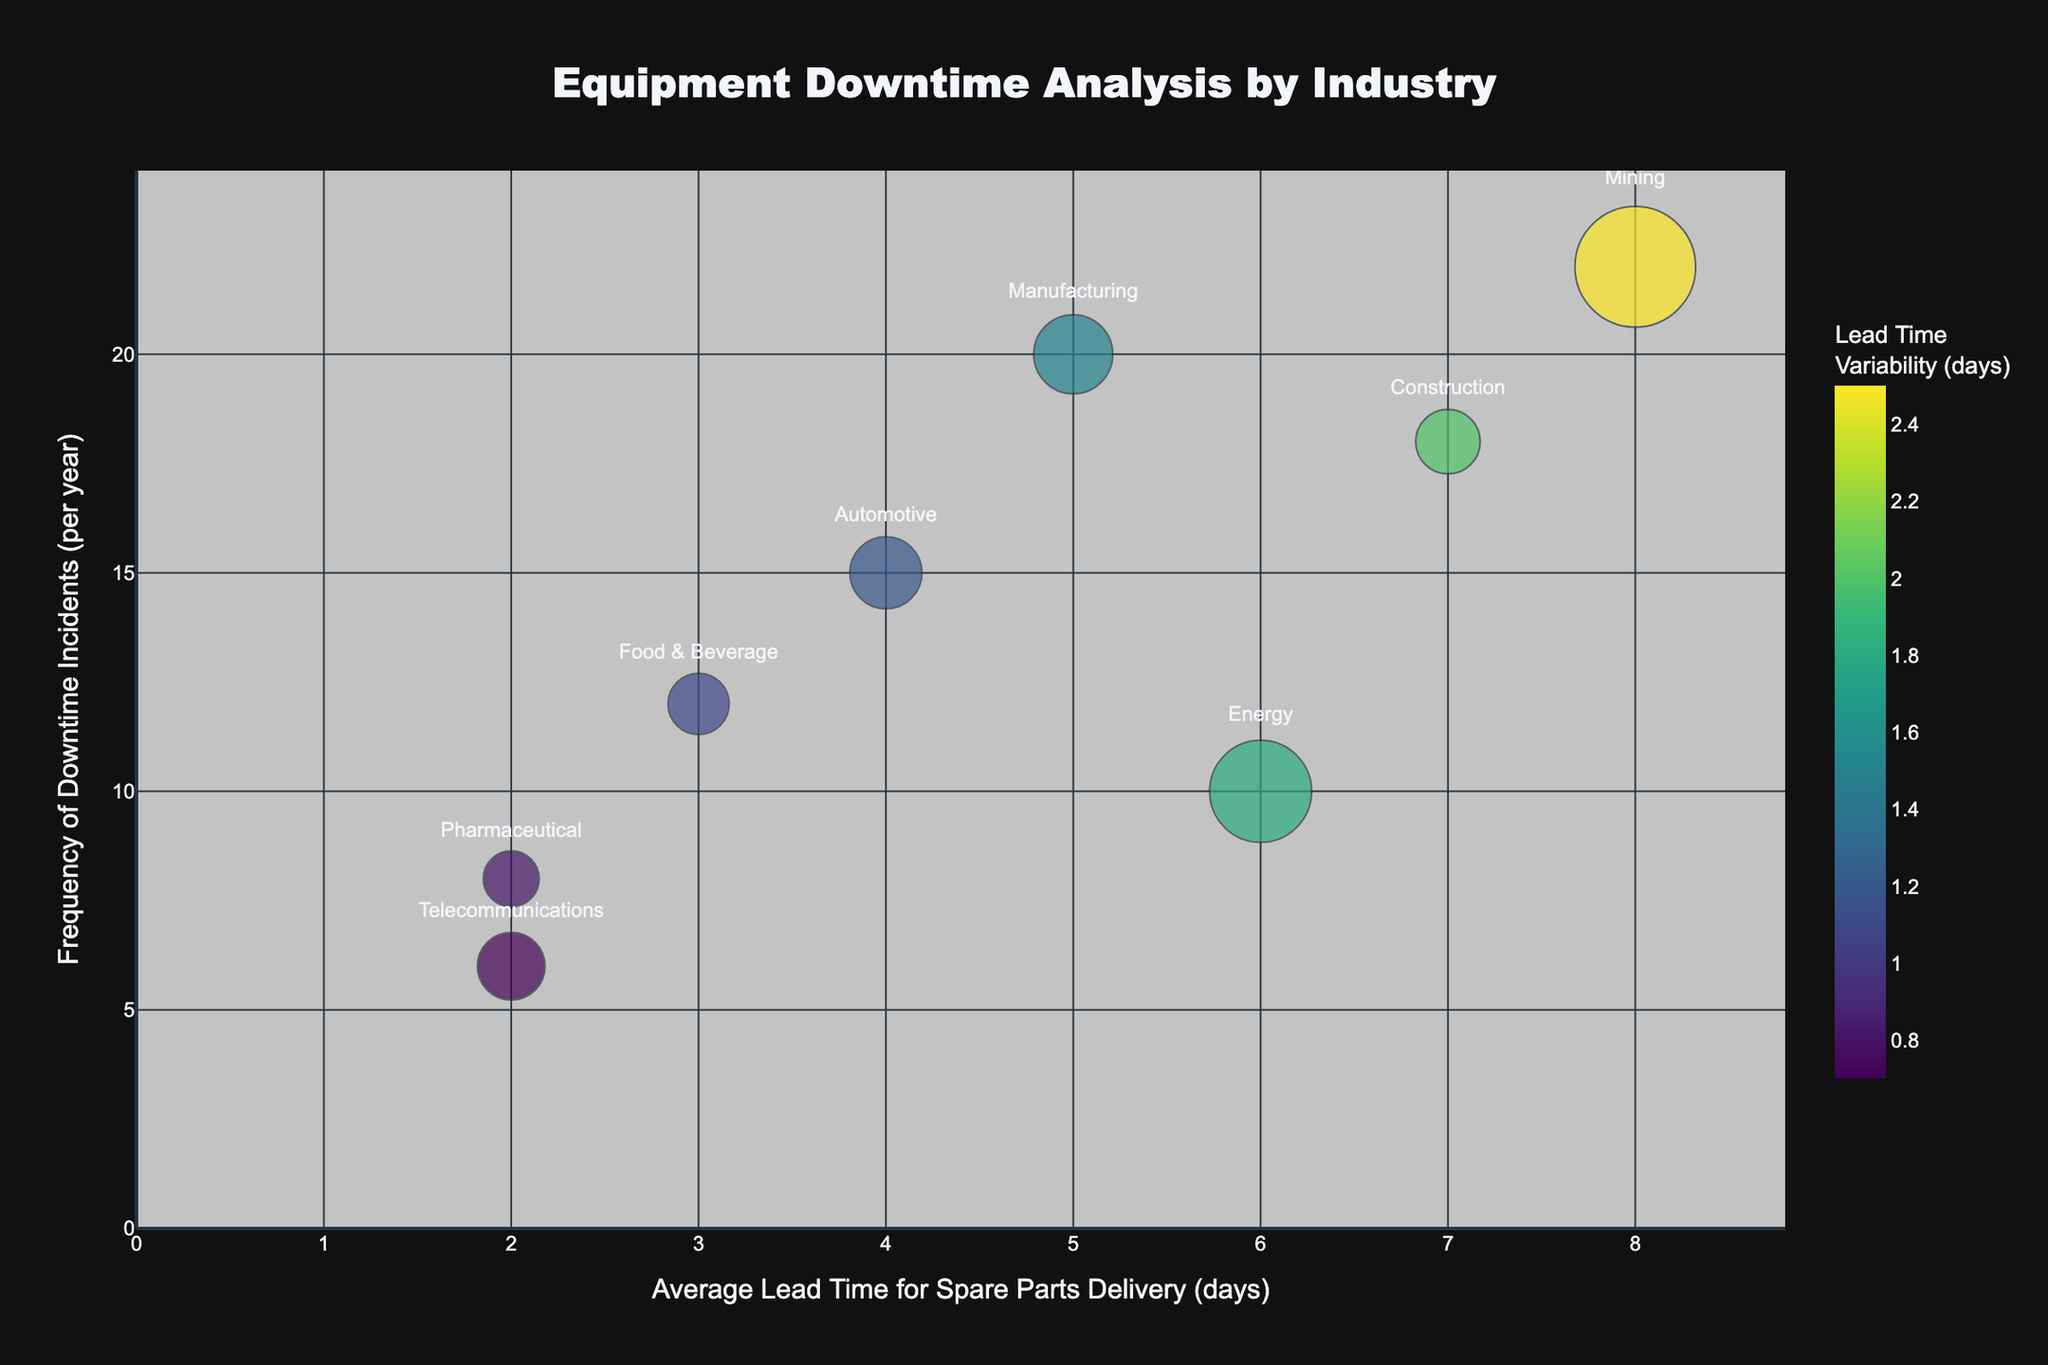How many industries are represented in the chart? Count the number of different industries shown on the bubble chart. Each industry is represented by a bubble labeled with its name.
Answer: 8 What is the industry with the highest frequency of downtime incidents per year? Locate the bubble that is furthest to the top along the y-axis (Frequency of Downtime Incidents per year). The corresponding industry name will be displayed near the bubble.
Answer: Mining Which industry has the shortest average lead time for spare parts delivery? Check the bubbles positioned the furthest to the left along the x-axis (Average Lead Time for Spare Parts Delivery in days). The corresponding industry name will be displayed near the bubble.
Answer: Pharmaceutical Which industry has the highest average downtime cost? Look for the bubble with the largest size, as the bubble size represents the Average Cost of Downtime (USD). The corresponding industry name will be displayed near the bubble.
Answer: Mining What is the average lead time for spare parts delivery in the construction industry? Identify the bubble labeled "Construction." Read the position of this bubble on the x-axis (Average Lead Time for Spare Parts Delivery in days).
Answer: 7 days How does the lead time variability of Telecommunications compare with that of Pharmaceutical? Identify the bubbles labeled "Telecommunications" and "Pharmaceutical" and compare the color (color represents Lead Time Variability). Darker color indicates higher variability.
Answer: Telecommunications has higher variability Which industry has both high frequency of incidents and high average downtime cost? Look for the bubble that is near the top of the y-axis (high frequency of downtime incidents) and is also large in size (high average cost).
Answer: Manufacturing Which two industries have the same average lead time for spare parts delivery but different frequencies of downtime incidents? Identify bubbles that share the same position on the x-axis (Average Lead Time for Spare Parts Delivery) but have different positions along the y-axis (Frequency of Downtime Incidents).
Answer: Telecommunications and Pharmaceutical Among Automotive and Manufacturing, which has a higher lead time variability? Locate the bubbles for "Automotive" and "Manufacturing" and compare their colors. The one with the darker shade represents higher variability.
Answer: Manufacturing What industry has a lead time of 4 days and what is its frequency of downtime incidents? Find the bubble positioned at 4 days on the x-axis (Average Lead Time for Spare Parts Delivery). Read the corresponding value along the y-axis for the frequency of downtime incidents.
Answer: Automotive; 15 per year 